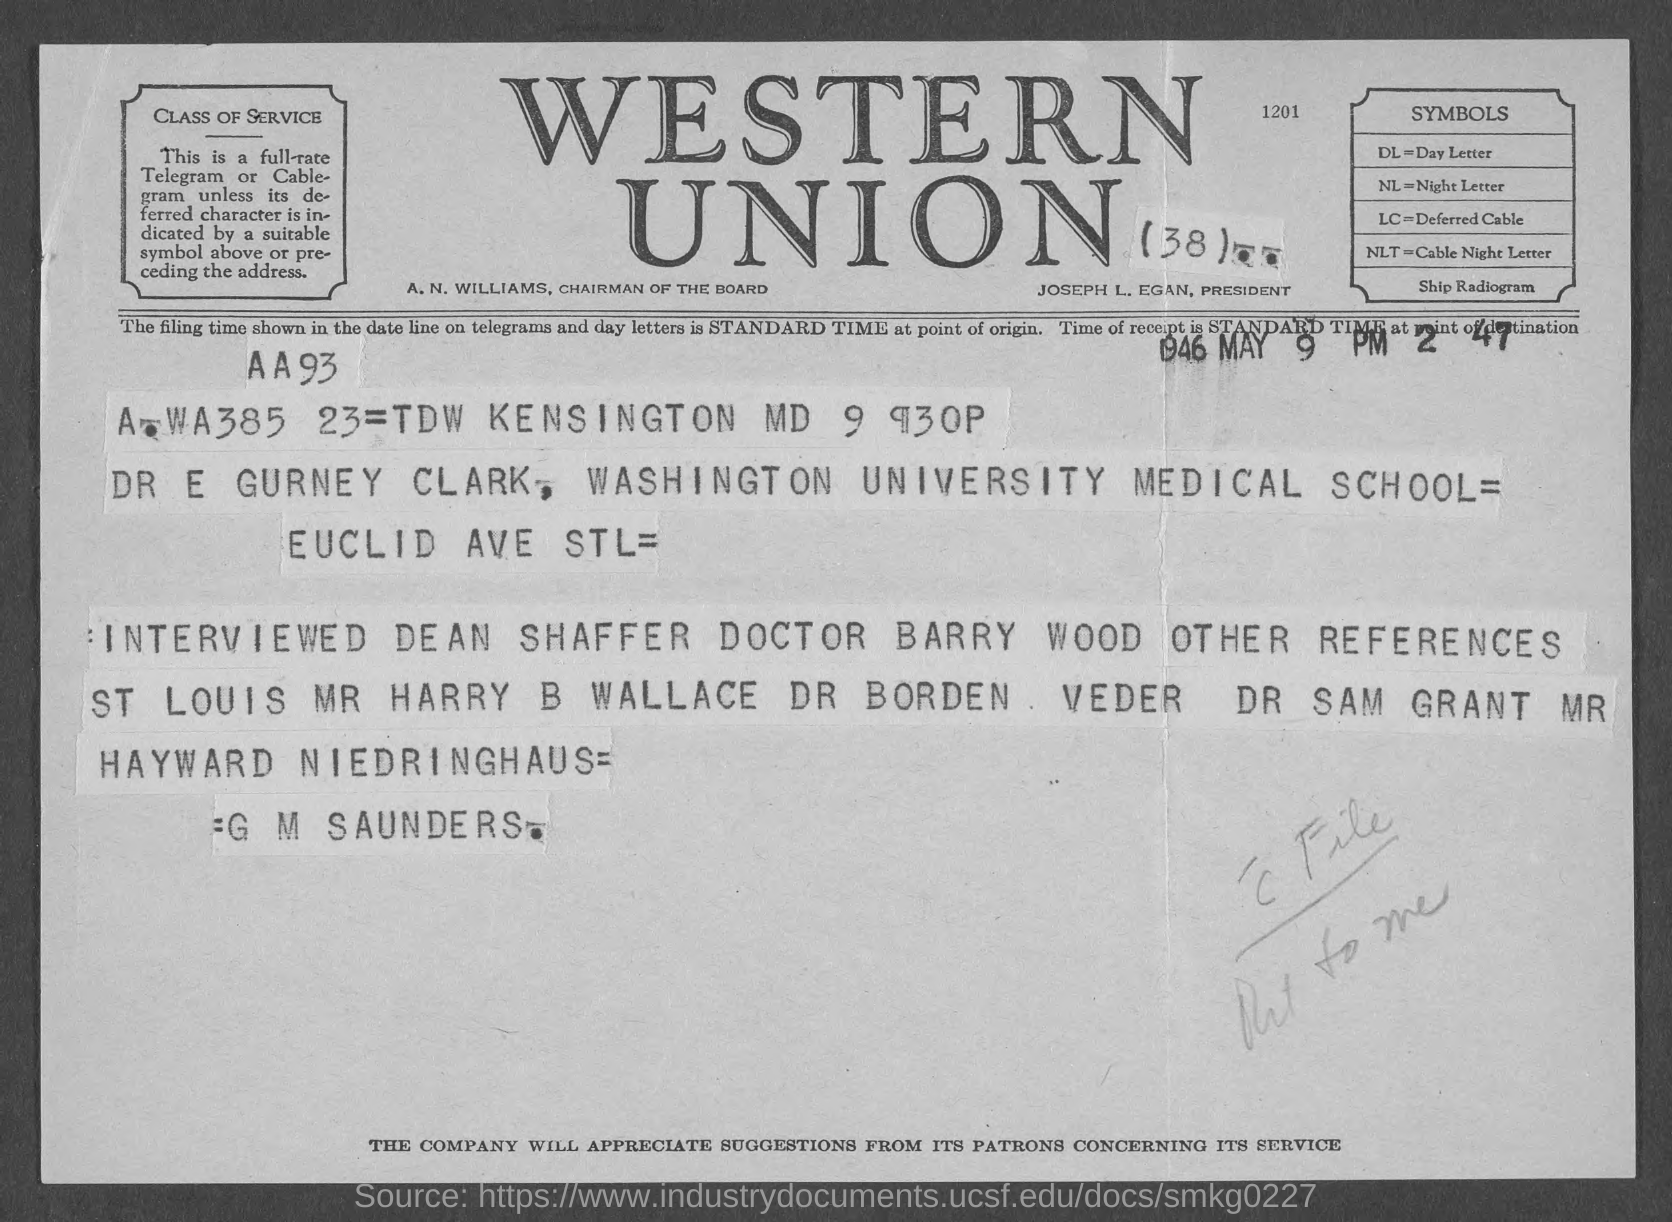What is the Fullform of NL ?
Offer a terse response. Night letter. What is the Fullform of DL ?
Your answer should be very brief. Day letter. Who is the President ?
Offer a very short reply. JOSEPH L. EGAN,. 